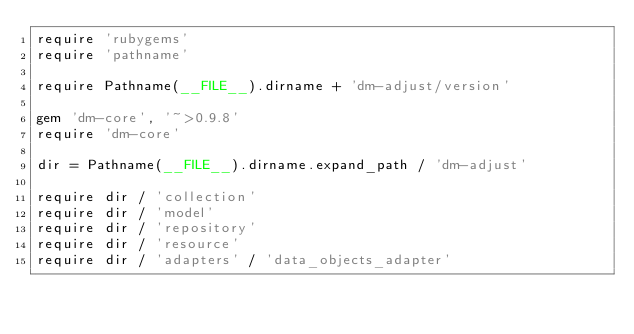Convert code to text. <code><loc_0><loc_0><loc_500><loc_500><_Ruby_>require 'rubygems'
require 'pathname'

require Pathname(__FILE__).dirname + 'dm-adjust/version'

gem 'dm-core', '~>0.9.8'
require 'dm-core'

dir = Pathname(__FILE__).dirname.expand_path / 'dm-adjust'

require dir / 'collection'
require dir / 'model'
require dir / 'repository'
require dir / 'resource'
require dir / 'adapters' / 'data_objects_adapter'
</code> 